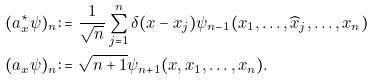<formula> <loc_0><loc_0><loc_500><loc_500>( a ^ { \ast } _ { x } \psi ) _ { n } \colon = & \ \frac { 1 } { \sqrt { n } } \sum ^ { n } _ { j = 1 } \delta ( x - x _ { j } ) \psi _ { n - 1 } ( x _ { 1 } , \dots , \widehat { x } _ { j } , \dots , x _ { n } ) \\ ( a _ { x } \psi ) _ { n } \colon = & \ \sqrt { n + 1 } \psi _ { n + 1 } ( x , x _ { 1 } , \dots , x _ { n } ) .</formula> 